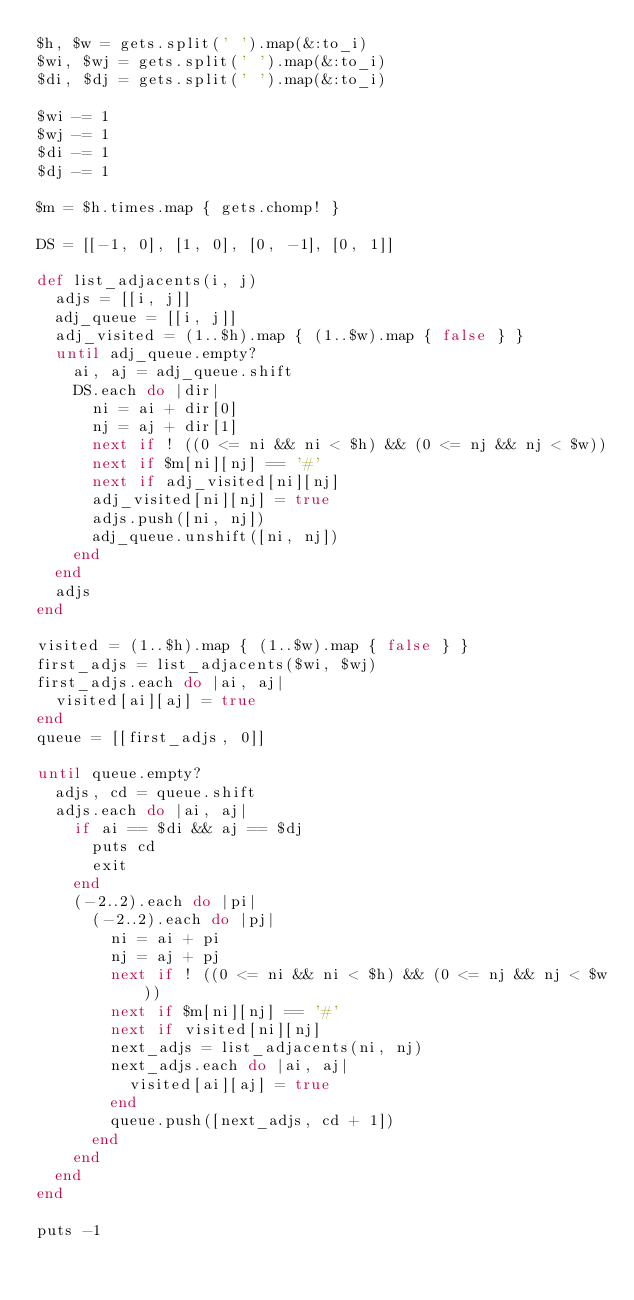Convert code to text. <code><loc_0><loc_0><loc_500><loc_500><_Ruby_>$h, $w = gets.split(' ').map(&:to_i)
$wi, $wj = gets.split(' ').map(&:to_i)
$di, $dj = gets.split(' ').map(&:to_i)

$wi -= 1
$wj -= 1
$di -= 1
$dj -= 1

$m = $h.times.map { gets.chomp! }

DS = [[-1, 0], [1, 0], [0, -1], [0, 1]]

def list_adjacents(i, j)
  adjs = [[i, j]]
  adj_queue = [[i, j]]
  adj_visited = (1..$h).map { (1..$w).map { false } }
  until adj_queue.empty?
    ai, aj = adj_queue.shift
    DS.each do |dir|
      ni = ai + dir[0]
      nj = aj + dir[1]
      next if ! ((0 <= ni && ni < $h) && (0 <= nj && nj < $w))
      next if $m[ni][nj] == '#'
      next if adj_visited[ni][nj]
      adj_visited[ni][nj] = true
      adjs.push([ni, nj])
      adj_queue.unshift([ni, nj])
    end
  end
  adjs
end

visited = (1..$h).map { (1..$w).map { false } }
first_adjs = list_adjacents($wi, $wj)
first_adjs.each do |ai, aj|
  visited[ai][aj] = true
end
queue = [[first_adjs, 0]]

until queue.empty?
  adjs, cd = queue.shift
  adjs.each do |ai, aj|
    if ai == $di && aj == $dj
      puts cd
      exit
    end
    (-2..2).each do |pi|
      (-2..2).each do |pj|
        ni = ai + pi
        nj = aj + pj
        next if ! ((0 <= ni && ni < $h) && (0 <= nj && nj < $w))
        next if $m[ni][nj] == '#'
        next if visited[ni][nj]
        next_adjs = list_adjacents(ni, nj)
        next_adjs.each do |ai, aj|
          visited[ai][aj] = true
        end
        queue.push([next_adjs, cd + 1])
      end
    end
  end
end

puts -1
</code> 